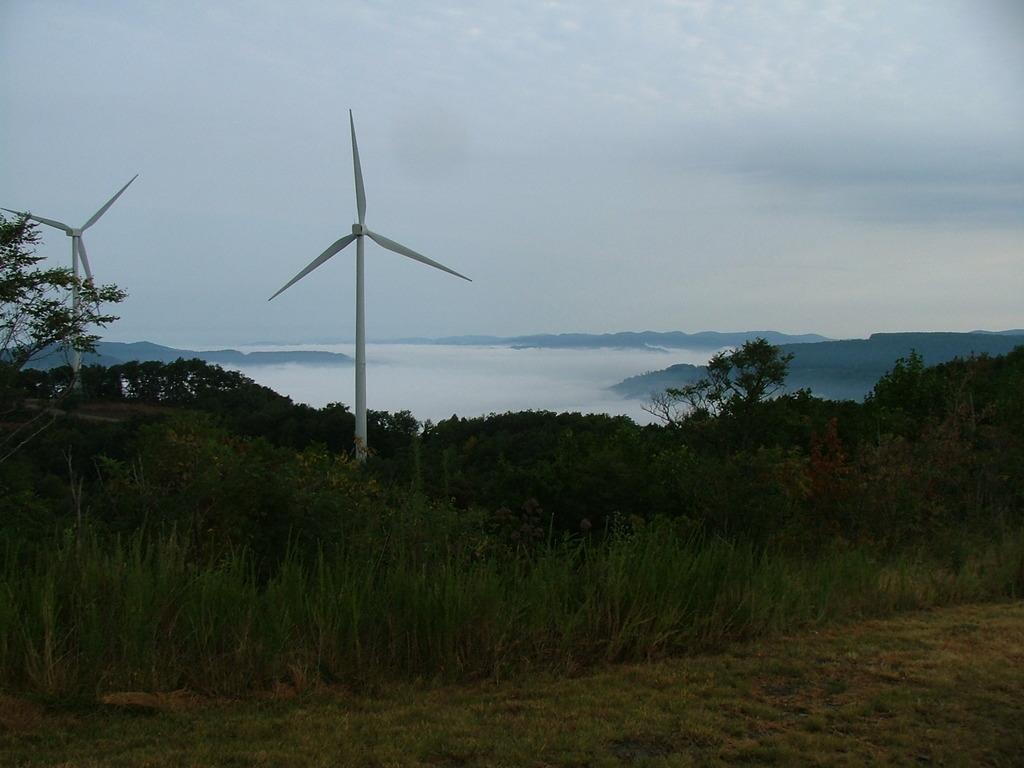Describe this image in one or two sentences. In the foreground of this image, there is grass, trees, wind fans, mountains, clouds and the sky. 